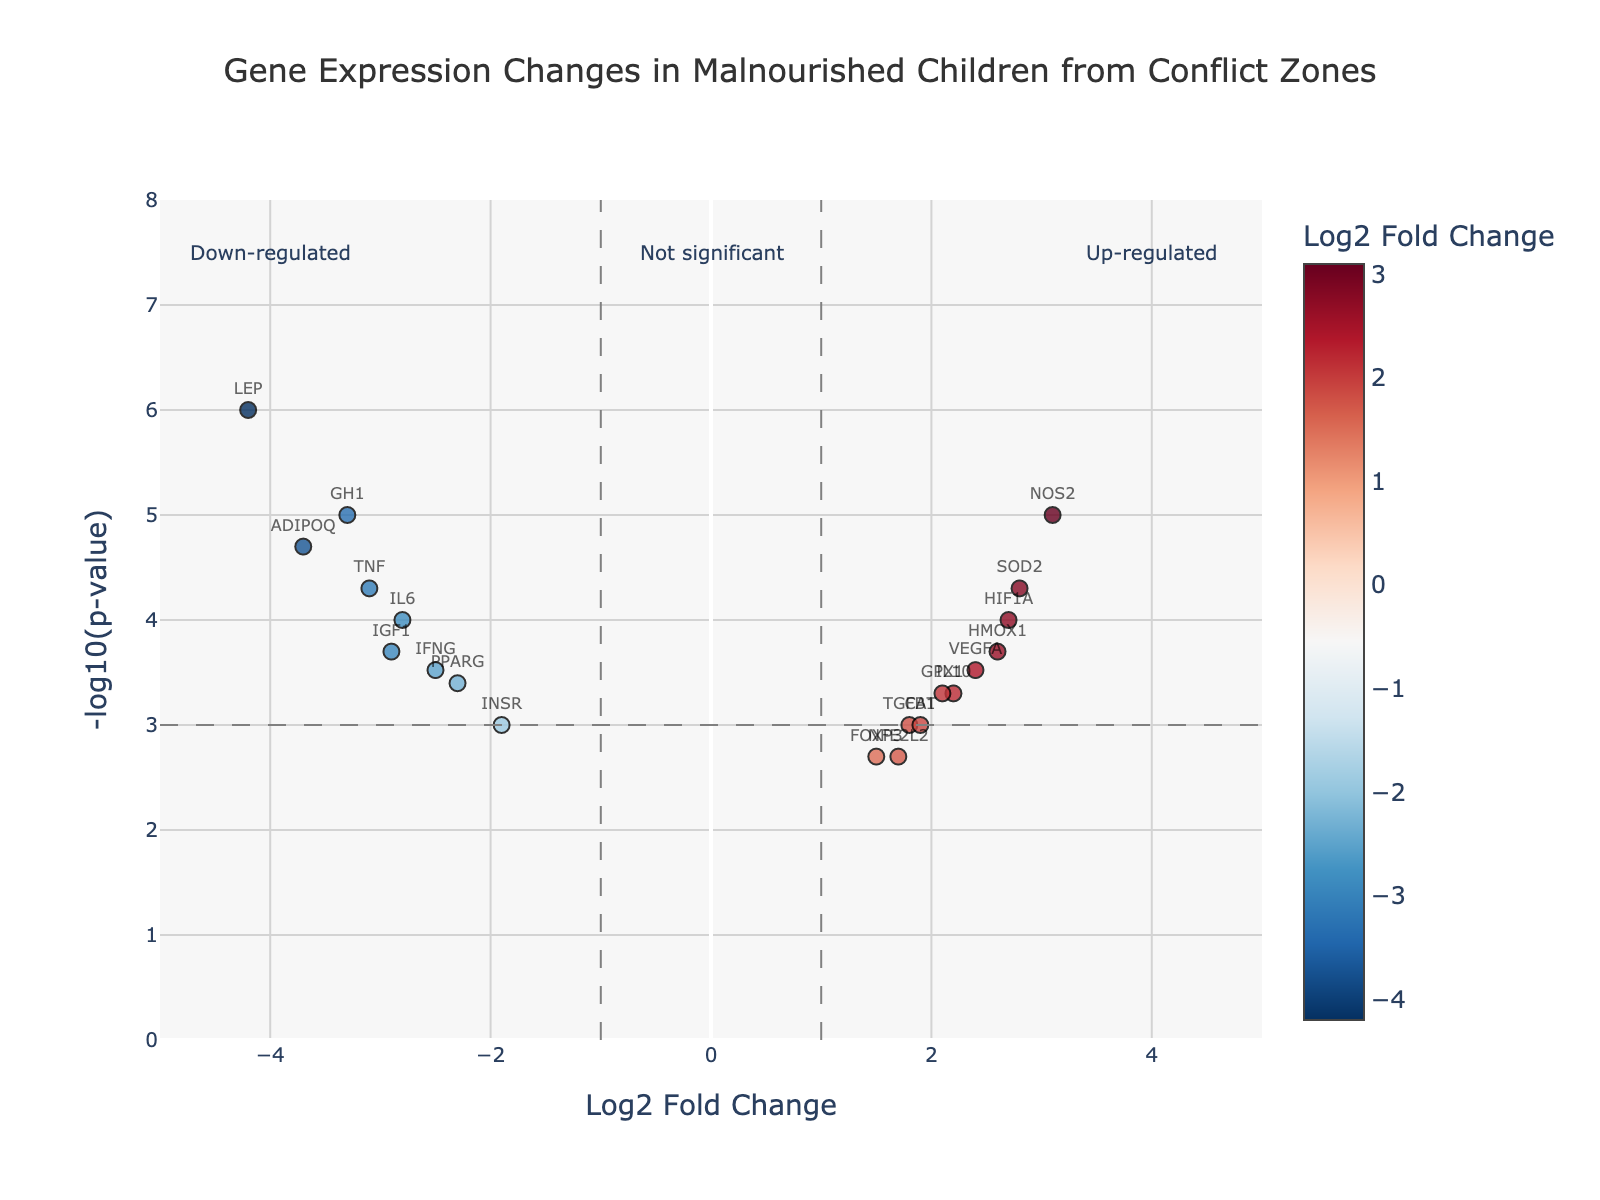Which gene has the highest log2 fold change? The highest log2 fold change can be identified by looking for the highest data point on the right side of the plot. NOS2 has the highest log2 fold change of 3.1.
Answer: NOS2 Which gene has the lowest log2 fold change? The lowest log2 fold change is identified by finding the most leftward data point. LEP has the lowest log2 fold change of -4.2.
Answer: LEP How many genes are significantly up-regulated? To be significantly up-regulated, the points must be to the right of the vertical line at log2 fold change of 1 and above the horizontal line at -log10(p-value) of 3. There are 6 such genes (TGFB1, IL10, FOXP3, HIF1A, VEGFA, NOS2, SOD2, CAT, GPX1, HMOX1, NFE2L2).
Answer: 9 Which genes are significantly down-regulated? For significant down-regulation, look for points left of the vertical line at log2 fold change of -1 and above the horizontal line at -log10(p-value) of 3. The genes are IL6, TNF, IFNG, LEP, ADIPOQ, GH1, and PPARG.
Answer: 7 Are there more up-regulated or down-regulated genes? Count the number of significantly up-regulated and significantly down-regulated genes. There are 9 up-regulated and 7 down-regulated genes.
Answer: More up-regulated What is the -log10(p-value) for the gene with the most significant change? The most significant p-value will correspond to the highest -log10(p-value). For LEP, the -log10(p-value) is the highest.
Answer: 6 Which genes fall in the "Not significant" category? Genes in the "Not significant" category fall between -1 and 1 in log2 fold change and below 3 in -log10(p-value). The genes are TGFB1, CAT, and INSR.
Answer: 3 Which gene has closest log2 fold change to zero but is still significant? For a gene closest to zero but still significant, it must be between -1 and 1 in log2 fold change and have a -log10(p-value) of at least 3. No such genes are significant.
Answer: None Which gene is located at (log2 FC: -2.5, -log10(p-value): 3.52)? Locate the specific point on the plot with log2 fold change of -2.5 and -log10(p-value) of approximately 3.52. IFNG is at these coordinates.
Answer: IFNG 